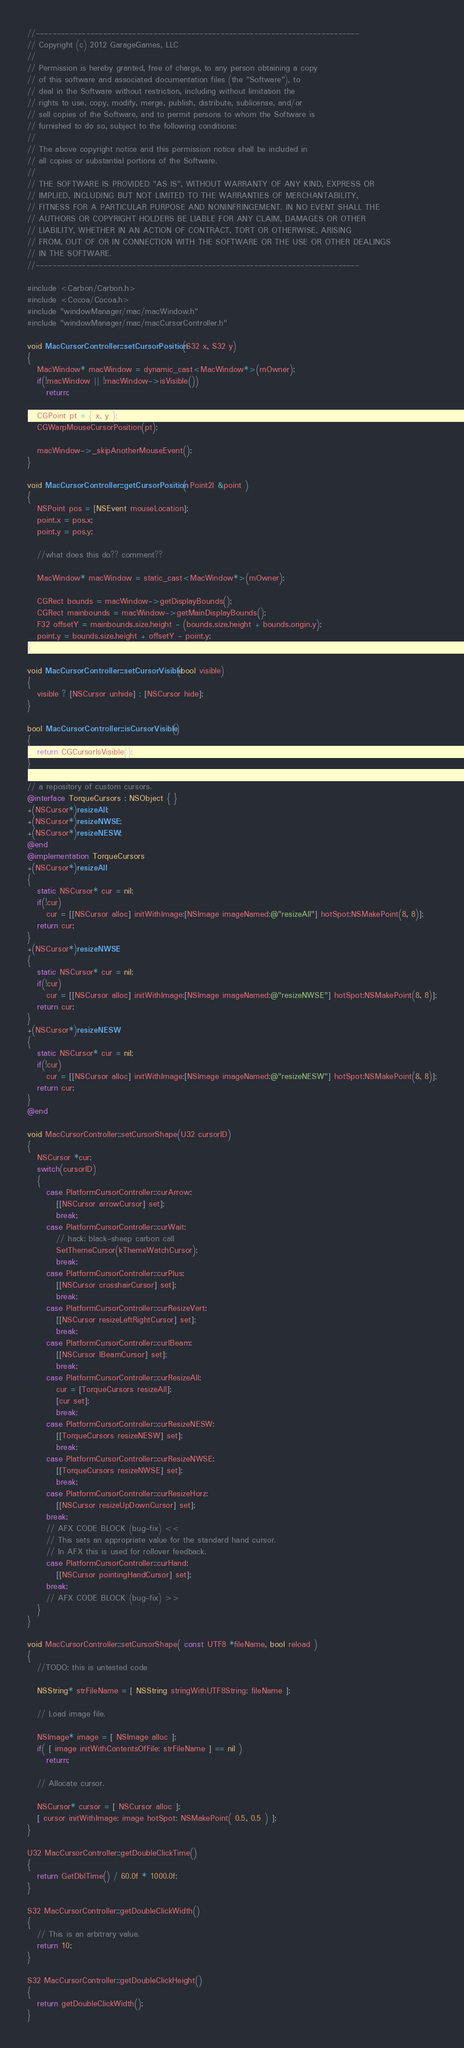Convert code to text. <code><loc_0><loc_0><loc_500><loc_500><_ObjectiveC_>//-----------------------------------------------------------------------------
// Copyright (c) 2012 GarageGames, LLC
//
// Permission is hereby granted, free of charge, to any person obtaining a copy
// of this software and associated documentation files (the "Software"), to
// deal in the Software without restriction, including without limitation the
// rights to use, copy, modify, merge, publish, distribute, sublicense, and/or
// sell copies of the Software, and to permit persons to whom the Software is
// furnished to do so, subject to the following conditions:
//
// The above copyright notice and this permission notice shall be included in
// all copies or substantial portions of the Software.
//
// THE SOFTWARE IS PROVIDED "AS IS", WITHOUT WARRANTY OF ANY KIND, EXPRESS OR
// IMPLIED, INCLUDING BUT NOT LIMITED TO THE WARRANTIES OF MERCHANTABILITY,
// FITNESS FOR A PARTICULAR PURPOSE AND NONINFRINGEMENT. IN NO EVENT SHALL THE
// AUTHORS OR COPYRIGHT HOLDERS BE LIABLE FOR ANY CLAIM, DAMAGES OR OTHER
// LIABILITY, WHETHER IN AN ACTION OF CONTRACT, TORT OR OTHERWISE, ARISING
// FROM, OUT OF OR IN CONNECTION WITH THE SOFTWARE OR THE USE OR OTHER DEALINGS
// IN THE SOFTWARE.
//-----------------------------------------------------------------------------

#include <Carbon/Carbon.h>
#include <Cocoa/Cocoa.h>
#include "windowManager/mac/macWindow.h"
#include "windowManager/mac/macCursorController.h"

void MacCursorController::setCursorPosition(S32 x, S32 y)
{
   MacWindow* macWindow = dynamic_cast<MacWindow*>(mOwner);
   if(!macWindow || !macWindow->isVisible())
      return;
      
   CGPoint pt = { x, y };
   CGWarpMouseCursorPosition(pt);
   
   macWindow->_skipAnotherMouseEvent();
}

void MacCursorController::getCursorPosition( Point2I &point )
{
   NSPoint pos = [NSEvent mouseLocation];
   point.x = pos.x;
   point.y = pos.y;
   
   //what does this do?? comment??
   
   MacWindow* macWindow = static_cast<MacWindow*>(mOwner);
   
   CGRect bounds = macWindow->getDisplayBounds();
   CGRect mainbounds = macWindow->getMainDisplayBounds();
   F32 offsetY = mainbounds.size.height - (bounds.size.height + bounds.origin.y);
   point.y = bounds.size.height + offsetY - point.y;
}

void MacCursorController::setCursorVisible(bool visible)
{
   visible ? [NSCursor unhide] : [NSCursor hide];
}

bool MacCursorController::isCursorVisible()
{
   return CGCursorIsVisible();
}

// a repository of custom cursors.
@interface TorqueCursors : NSObject { }
+(NSCursor*)resizeAll;
+(NSCursor*)resizeNWSE;
+(NSCursor*)resizeNESW;
@end
@implementation TorqueCursors
+(NSCursor*)resizeAll
{
   static NSCursor* cur = nil;
   if(!cur)
      cur = [[NSCursor alloc] initWithImage:[NSImage imageNamed:@"resizeAll"] hotSpot:NSMakePoint(8, 8)];
   return cur;
}
+(NSCursor*)resizeNWSE
{
   static NSCursor* cur = nil;
   if(!cur)
      cur = [[NSCursor alloc] initWithImage:[NSImage imageNamed:@"resizeNWSE"] hotSpot:NSMakePoint(8, 8)];
   return cur;
}
+(NSCursor*)resizeNESW
{
   static NSCursor* cur = nil;
   if(!cur)
      cur = [[NSCursor alloc] initWithImage:[NSImage imageNamed:@"resizeNESW"] hotSpot:NSMakePoint(8, 8)];
   return cur;
}
@end

void MacCursorController::setCursorShape(U32 cursorID)
{
   NSCursor *cur;
   switch(cursorID)
   {
      case PlatformCursorController::curArrow:
         [[NSCursor arrowCursor] set];
         break;
      case PlatformCursorController::curWait:
         // hack: black-sheep carbon call
         SetThemeCursor(kThemeWatchCursor);
         break;
      case PlatformCursorController::curPlus:
         [[NSCursor crosshairCursor] set];
         break;
      case PlatformCursorController::curResizeVert:
         [[NSCursor resizeLeftRightCursor] set];
         break;
      case PlatformCursorController::curIBeam:
         [[NSCursor IBeamCursor] set];
         break;
      case PlatformCursorController::curResizeAll:
         cur = [TorqueCursors resizeAll];
         [cur set];
         break;
      case PlatformCursorController::curResizeNESW:
         [[TorqueCursors resizeNESW] set];
         break;
      case PlatformCursorController::curResizeNWSE:
         [[TorqueCursors resizeNWSE] set];
         break;
      case PlatformCursorController::curResizeHorz:
         [[NSCursor resizeUpDownCursor] set];
      break;
      // AFX CODE BLOCK (bug-fix) <<
      // This sets an appropriate value for the standard hand cursor.
      // In AFX this is used for rollover feedback.
      case PlatformCursorController::curHand:
         [[NSCursor pointingHandCursor] set];
      break;
      // AFX CODE BLOCK (bug-fix) >>
   }
}

void MacCursorController::setCursorShape( const UTF8 *fileName, bool reload )
{
   //TODO: this is untested code
   
   NSString* strFileName = [ NSString stringWithUTF8String: fileName ];
   
   // Load image file.
   
   NSImage* image = [ NSImage alloc ];
   if( [ image initWithContentsOfFile: strFileName ] == nil )
      return;

   // Allocate cursor.
   
   NSCursor* cursor = [ NSCursor alloc ];
   [ cursor initWithImage: image hotSpot: NSMakePoint( 0.5, 0.5 ) ];
}

U32 MacCursorController::getDoubleClickTime()
{
   return GetDblTime() / 60.0f * 1000.0f;
}

S32 MacCursorController::getDoubleClickWidth()
{
   // This is an arbitrary value.
   return 10;
}

S32 MacCursorController::getDoubleClickHeight()
{
   return getDoubleClickWidth();
}

</code> 